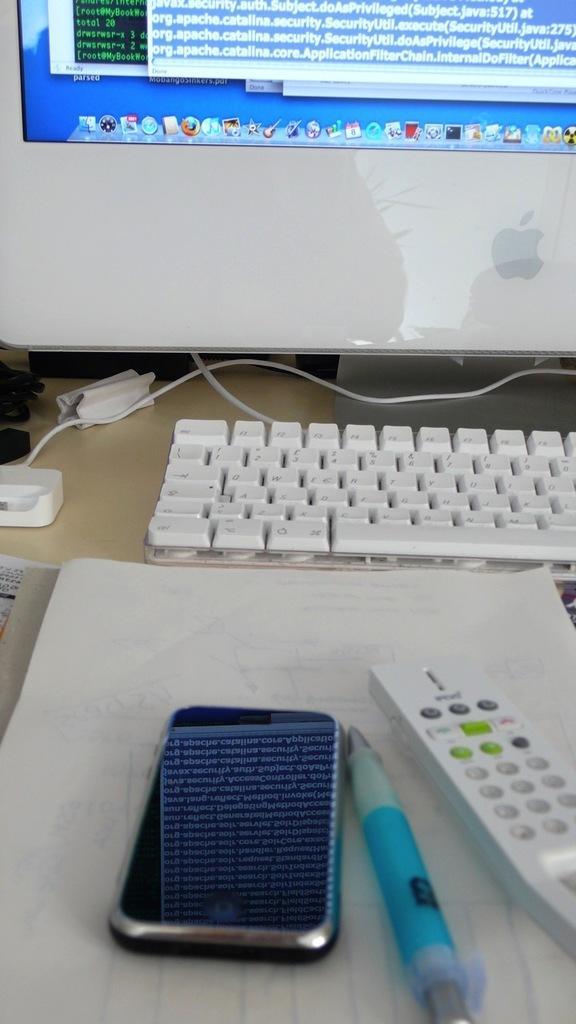Please provide a concise description of this image. In this picture there is a computer, mobile, remote and a pen placed on a computer table. We can observe some wires on the table. There is a book here. 